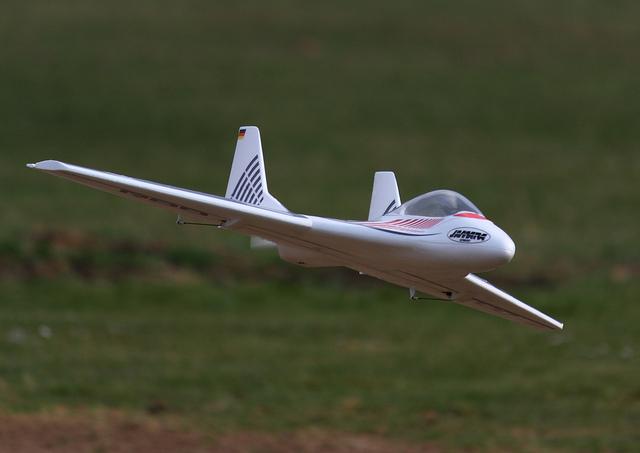What country's flag is being displayed on tail of the plane?
Concise answer only. Usa. How many people in the plane?
Short answer required. 0. Is this a toy?
Quick response, please. Yes. 